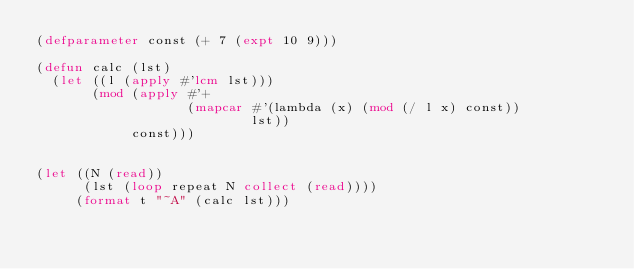Convert code to text. <code><loc_0><loc_0><loc_500><loc_500><_Lisp_>(defparameter const (+ 7 (expt 10 9)))

(defun calc (lst)
  (let ((l (apply #'lcm lst)))
       (mod (apply #'+
                   (mapcar #'(lambda (x) (mod (/ l x) const))
                           lst))
            const)))


(let ((N (read))
      (lst (loop repeat N collect (read))))
     (format t "~A" (calc lst)))</code> 